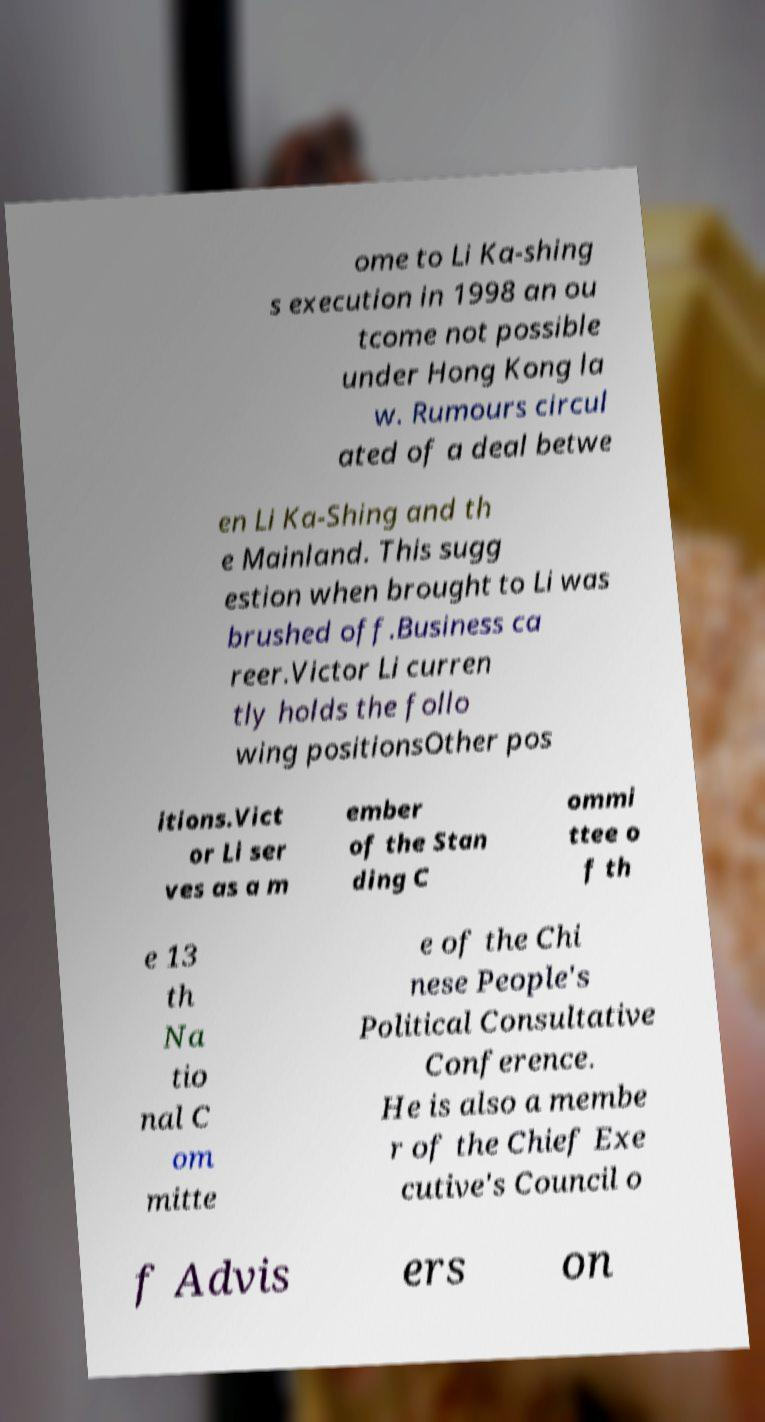For documentation purposes, I need the text within this image transcribed. Could you provide that? ome to Li Ka-shing s execution in 1998 an ou tcome not possible under Hong Kong la w. Rumours circul ated of a deal betwe en Li Ka-Shing and th e Mainland. This sugg estion when brought to Li was brushed off.Business ca reer.Victor Li curren tly holds the follo wing positionsOther pos itions.Vict or Li ser ves as a m ember of the Stan ding C ommi ttee o f th e 13 th Na tio nal C om mitte e of the Chi nese People's Political Consultative Conference. He is also a membe r of the Chief Exe cutive's Council o f Advis ers on 